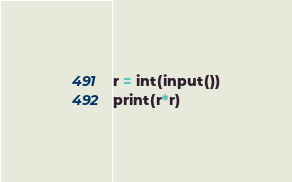Convert code to text. <code><loc_0><loc_0><loc_500><loc_500><_Python_>r = int(input())
print(r*r)</code> 